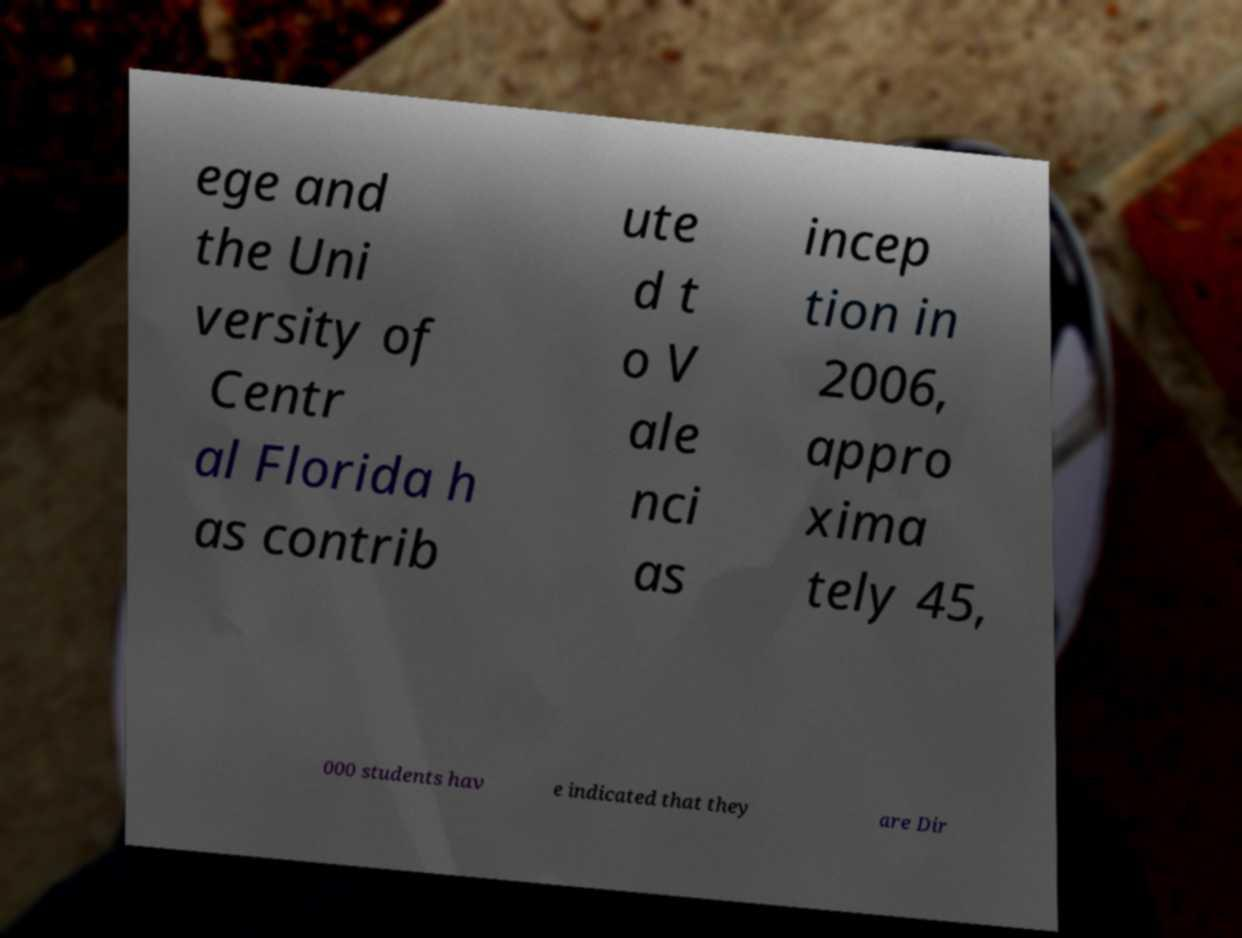Could you extract and type out the text from this image? ege and the Uni versity of Centr al Florida h as contrib ute d t o V ale nci as incep tion in 2006, appro xima tely 45, 000 students hav e indicated that they are Dir 